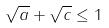<formula> <loc_0><loc_0><loc_500><loc_500>\sqrt { a } + \sqrt { c } \leq 1</formula> 